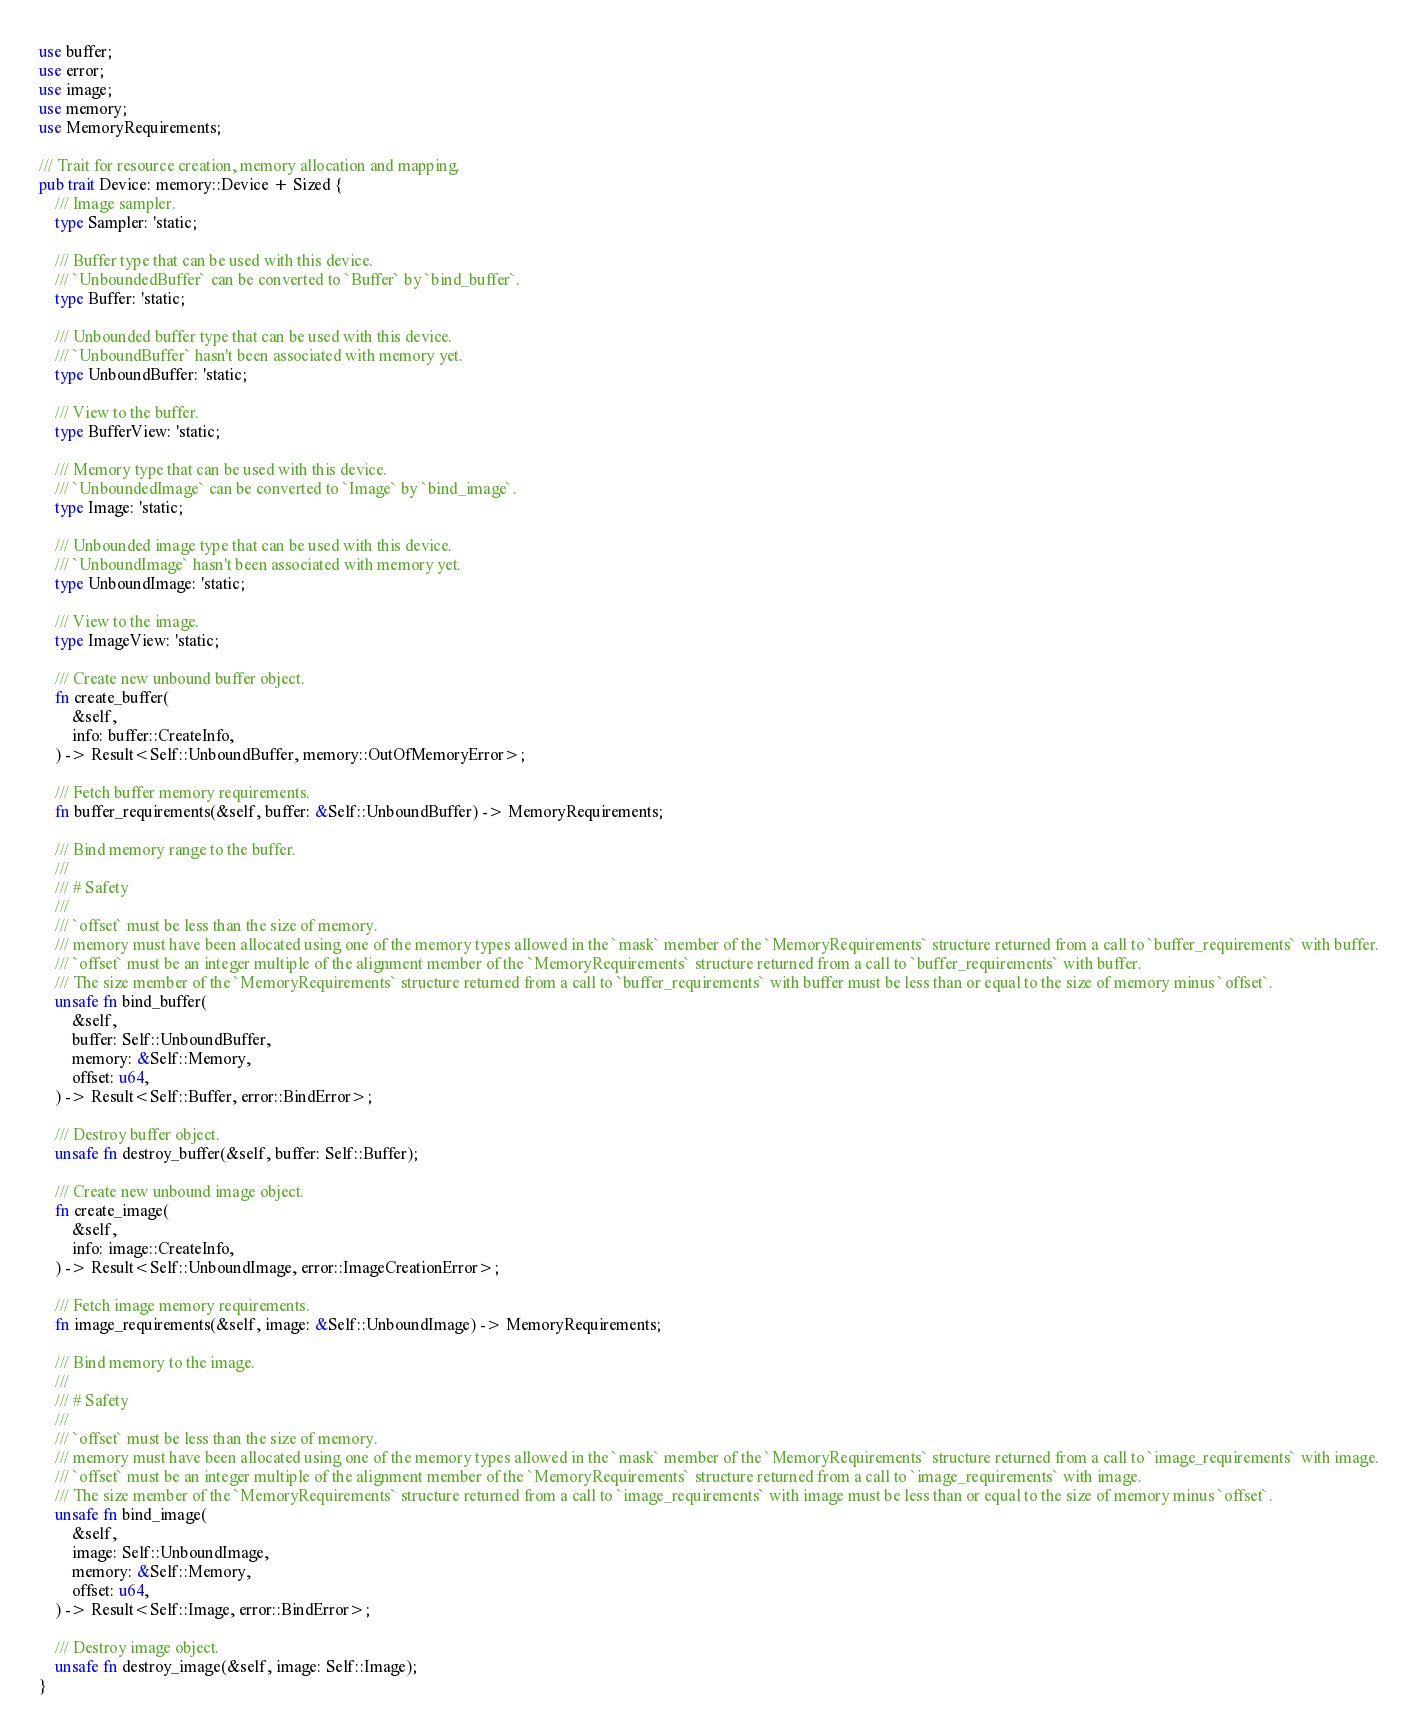Convert code to text. <code><loc_0><loc_0><loc_500><loc_500><_Rust_>use buffer;
use error;
use image;
use memory;
use MemoryRequirements;

/// Trait for resource creation, memory allocation and mapping.
pub trait Device: memory::Device + Sized {
    /// Image sampler.
    type Sampler: 'static;

    /// Buffer type that can be used with this device.
    /// `UnboundedBuffer` can be converted to `Buffer` by `bind_buffer`.
    type Buffer: 'static;

    /// Unbounded buffer type that can be used with this device.
    /// `UnboundBuffer` hasn't been associated with memory yet.
    type UnboundBuffer: 'static;

    /// View to the buffer.
    type BufferView: 'static;

    /// Memory type that can be used with this device.
    /// `UnboundedImage` can be converted to `Image` by `bind_image`.
    type Image: 'static;

    /// Unbounded image type that can be used with this device.
    /// `UnboundImage` hasn't been associated with memory yet.
    type UnboundImage: 'static;

    /// View to the image.
    type ImageView: 'static;

    /// Create new unbound buffer object.
    fn create_buffer(
        &self,
        info: buffer::CreateInfo,
    ) -> Result<Self::UnboundBuffer, memory::OutOfMemoryError>;

    /// Fetch buffer memory requirements.
    fn buffer_requirements(&self, buffer: &Self::UnboundBuffer) -> MemoryRequirements;

    /// Bind memory range to the buffer.
    ///
    /// # Safety
    ///
    /// `offset` must be less than the size of memory.
    /// memory must have been allocated using one of the memory types allowed in the `mask` member of the `MemoryRequirements` structure returned from a call to `buffer_requirements` with buffer.
    /// `offset` must be an integer multiple of the alignment member of the `MemoryRequirements` structure returned from a call to `buffer_requirements` with buffer.
    /// The size member of the `MemoryRequirements` structure returned from a call to `buffer_requirements` with buffer must be less than or equal to the size of memory minus `offset`.
    unsafe fn bind_buffer(
        &self,
        buffer: Self::UnboundBuffer,
        memory: &Self::Memory,
        offset: u64,
    ) -> Result<Self::Buffer, error::BindError>;

    /// Destroy buffer object.
    unsafe fn destroy_buffer(&self, buffer: Self::Buffer);

    /// Create new unbound image object.
    fn create_image(
        &self,
        info: image::CreateInfo,
    ) -> Result<Self::UnboundImage, error::ImageCreationError>;

    /// Fetch image memory requirements.
    fn image_requirements(&self, image: &Self::UnboundImage) -> MemoryRequirements;

    /// Bind memory to the image.
    ///
    /// # Safety
    ///
    /// `offset` must be less than the size of memory.
    /// memory must have been allocated using one of the memory types allowed in the `mask` member of the `MemoryRequirements` structure returned from a call to `image_requirements` with image.
    /// `offset` must be an integer multiple of the alignment member of the `MemoryRequirements` structure returned from a call to `image_requirements` with image.
    /// The size member of the `MemoryRequirements` structure returned from a call to `image_requirements` with image must be less than or equal to the size of memory minus `offset`.
    unsafe fn bind_image(
        &self,
        image: Self::UnboundImage,
        memory: &Self::Memory,
        offset: u64,
    ) -> Result<Self::Image, error::BindError>;

    /// Destroy image object.
    unsafe fn destroy_image(&self, image: Self::Image);
}
</code> 